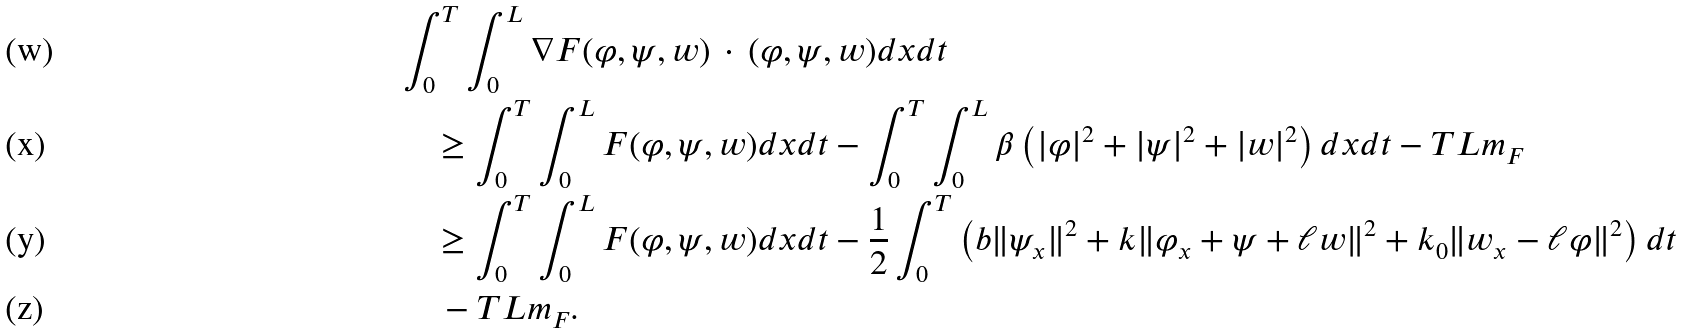Convert formula to latex. <formula><loc_0><loc_0><loc_500><loc_500>& \int _ { 0 } ^ { T } \int _ { 0 } ^ { L } \nabla F ( \varphi , \psi , w ) \, \cdot \, ( \varphi , \psi , w ) d x d t \\ & \quad \geq \int _ { 0 } ^ { T } \int _ { 0 } ^ { L } F ( \varphi , \psi , w ) d x d t - \int _ { 0 } ^ { T } \int _ { 0 } ^ { L } \beta \left ( | \varphi | ^ { 2 } + | \psi | ^ { 2 } + | w | ^ { 2 } \right ) d x d t - T L m _ { F } \\ & \quad \geq \int _ { 0 } ^ { T } \int _ { 0 } ^ { L } F ( \varphi , \psi , w ) d x d t - \frac { 1 } { 2 } \int _ { 0 } ^ { T } \left ( b \| \psi _ { x } \| ^ { 2 } + k \| \varphi _ { x } + \psi + \ell w \| ^ { 2 } + k _ { 0 } \| w _ { x } - \ell \varphi \| ^ { 2 } \right ) d t \\ & \quad \, - T L m _ { F } .</formula> 